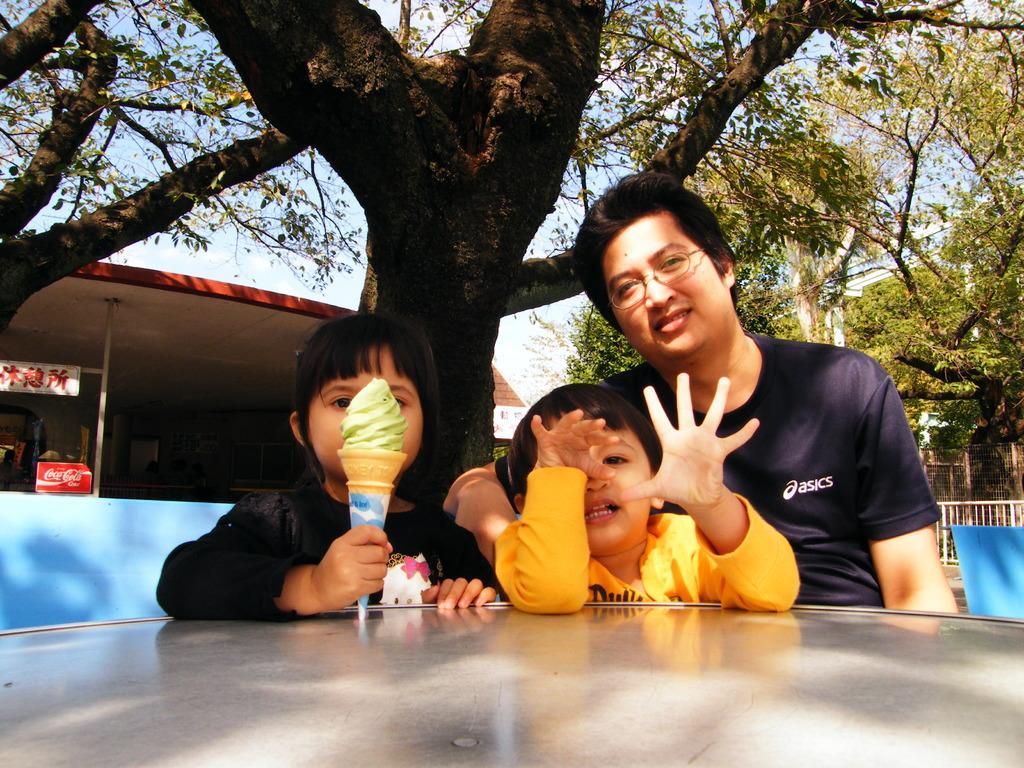Describe this image in one or two sentences. In this image there are three persons sitting on the chair. In front of them there is a table. At the background there are trees and buildings. At the top there is sky. 